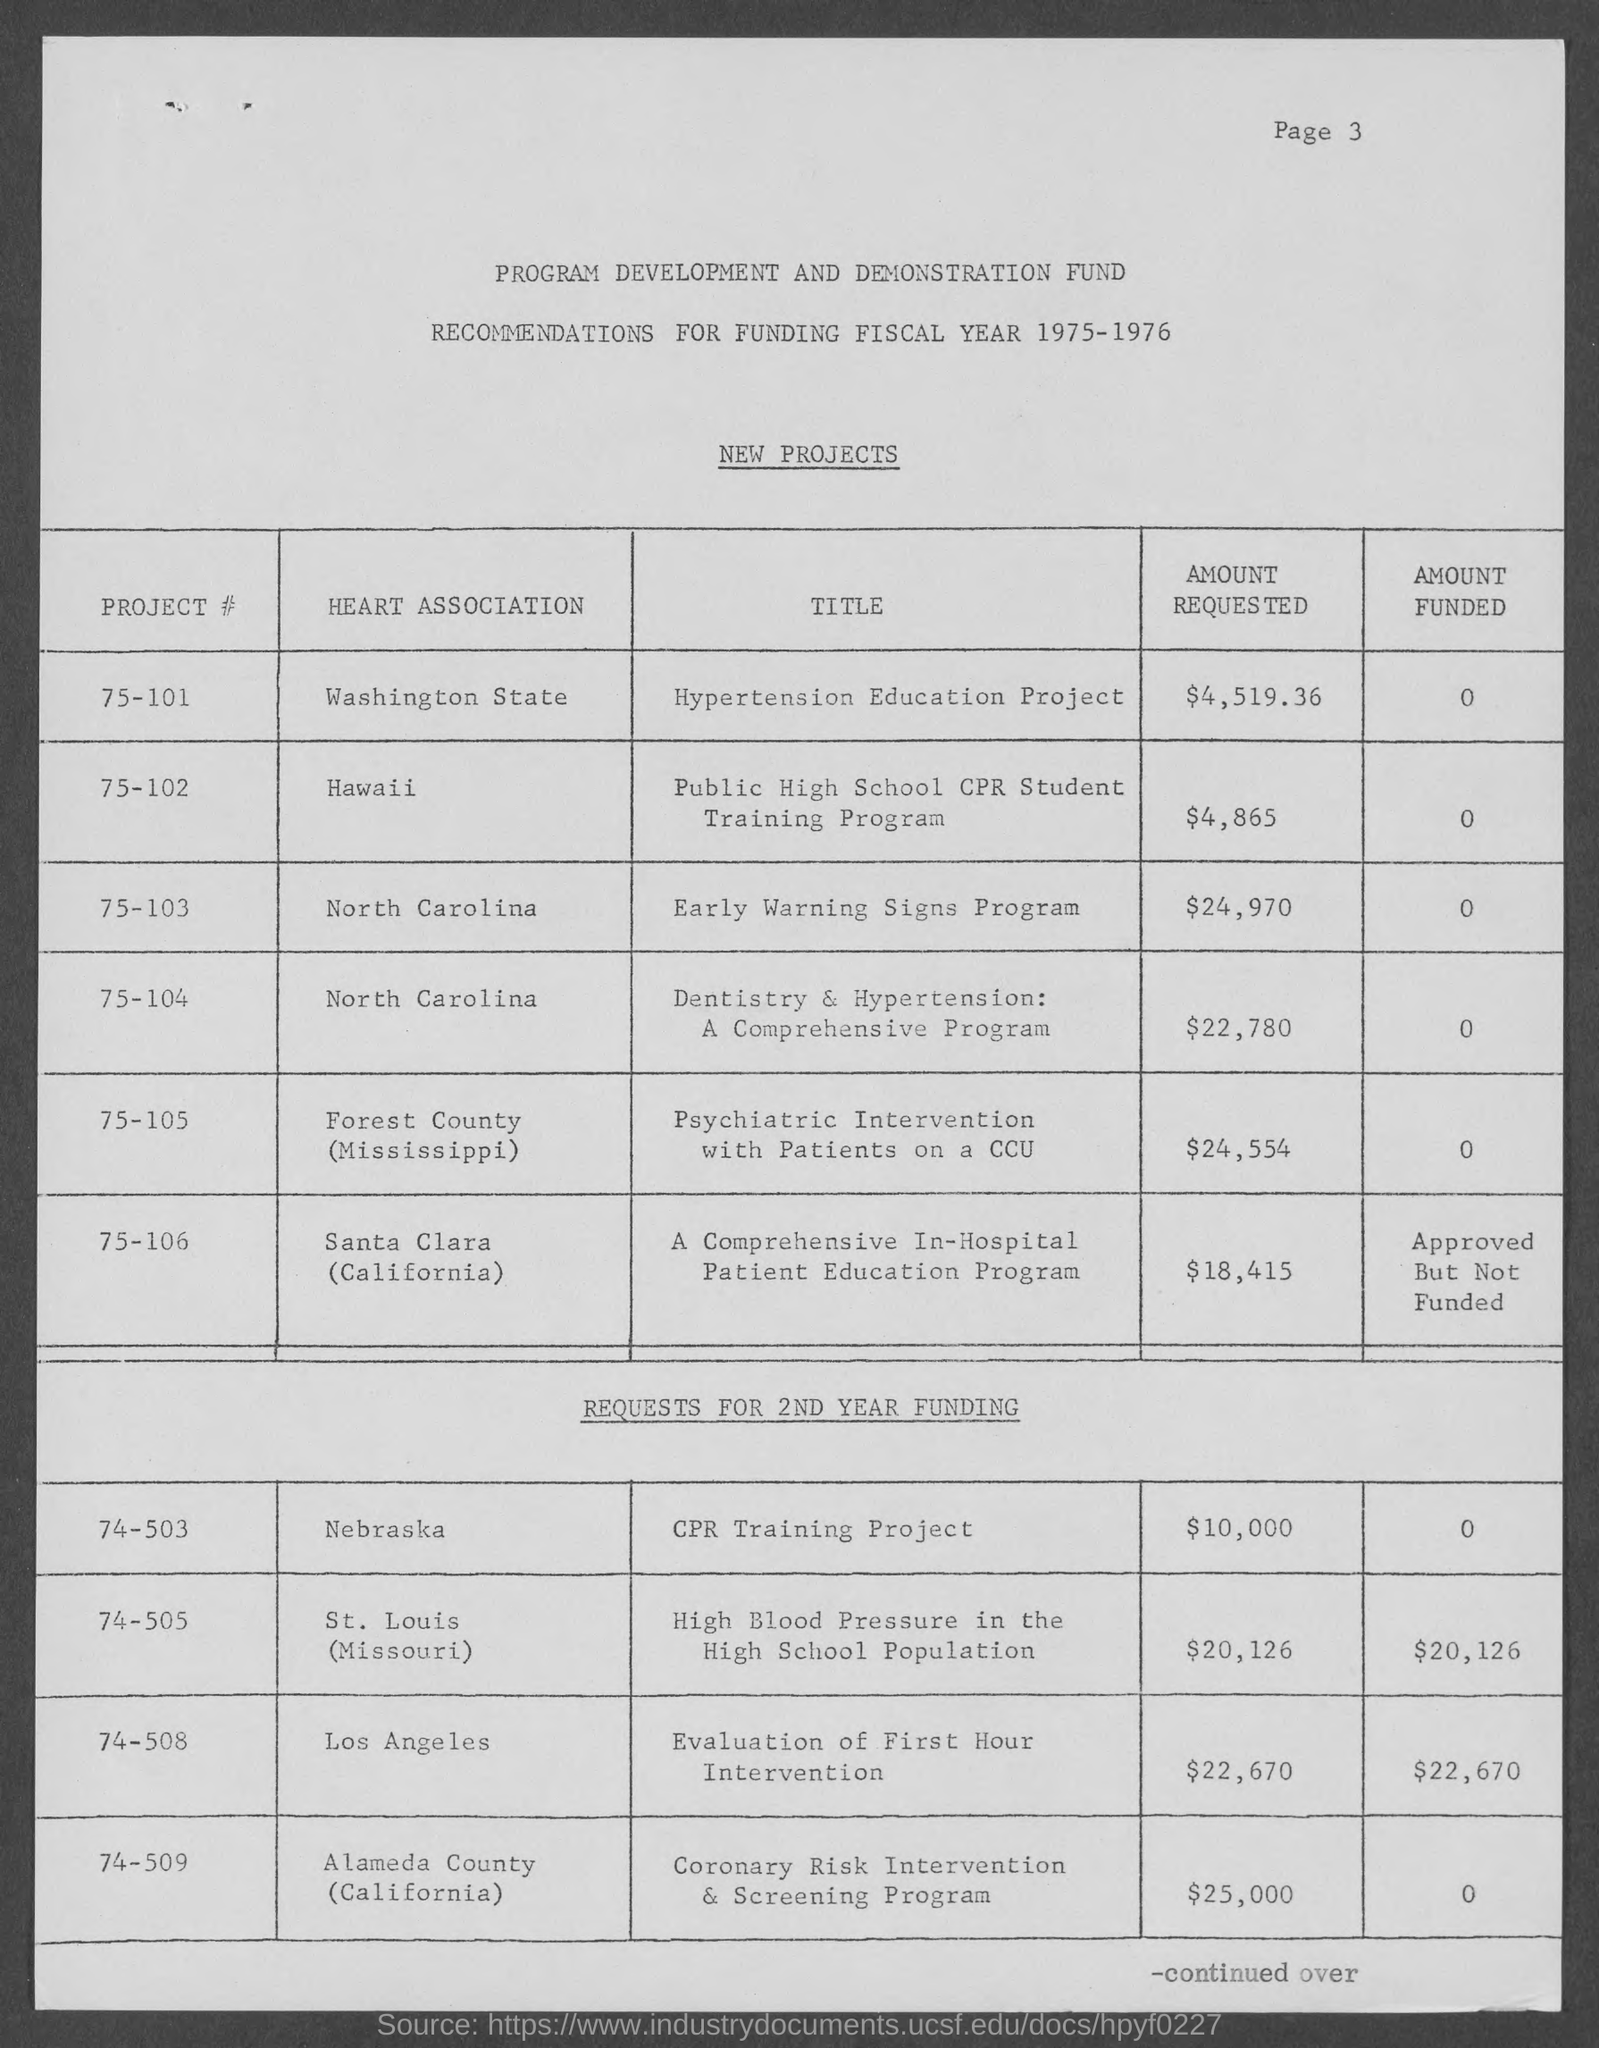What is the page number at top of the page?
Offer a very short reply. 3. To which fiscal year are recommendations for ?
Make the answer very short. 1975-1976. What is the amount requested for public high school cpr student training program?
Provide a short and direct response. $4,865. What is the amount requested for early warning signs program?
Ensure brevity in your answer.  $24,970. What is the amount requested for dentistry & hypertension : a comprehensive program?
Ensure brevity in your answer.  $22,780. 